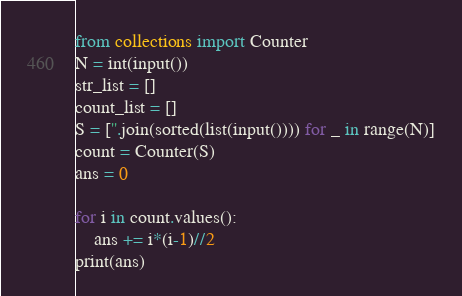<code> <loc_0><loc_0><loc_500><loc_500><_Python_>from collections import Counter
N = int(input())
str_list = []
count_list = []
S = [''.join(sorted(list(input()))) for _ in range(N)]
count = Counter(S)
ans = 0

for i in count.values():
    ans += i*(i-1)//2
print(ans)</code> 